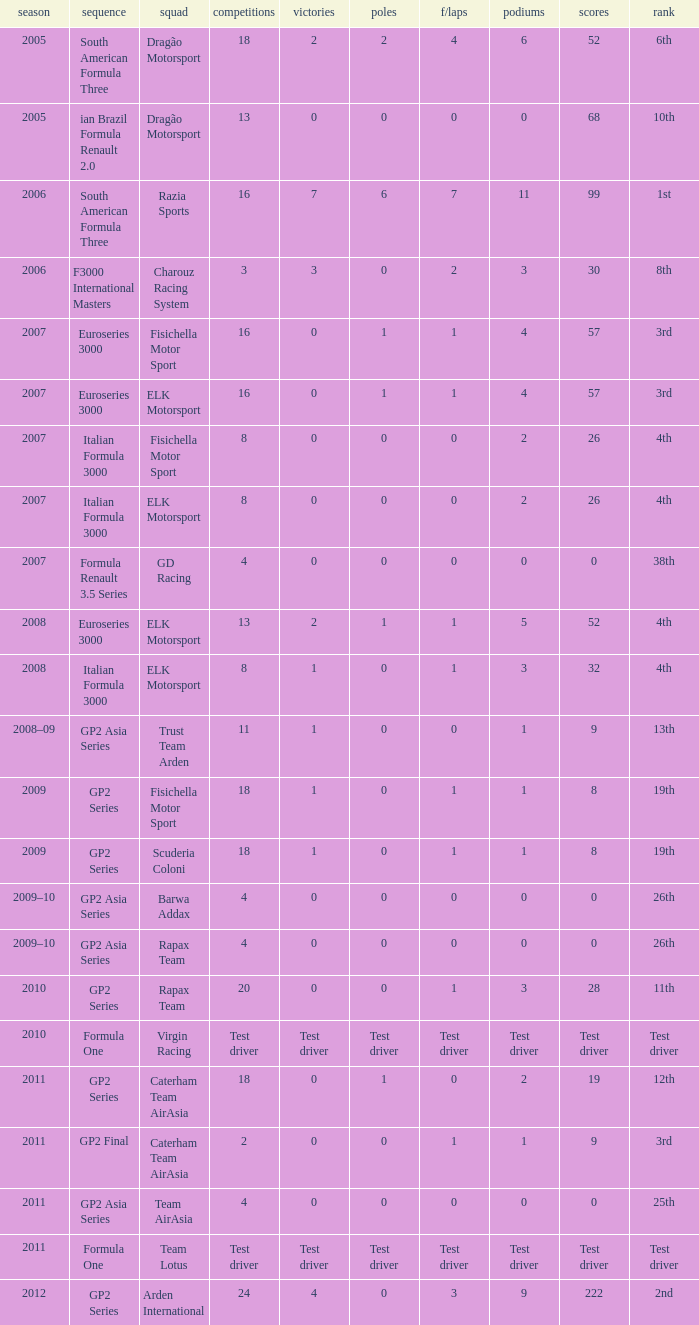How many races did he do in the year he had 8 points? 18, 18. 